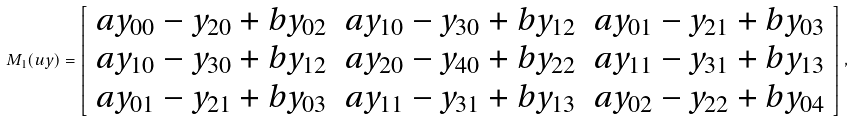Convert formula to latex. <formula><loc_0><loc_0><loc_500><loc_500>{ M } _ { 1 } ( u y ) = \left [ \begin{array} { c c c c c c } a y _ { 0 0 } - y _ { 2 0 } + b y _ { 0 2 } & a y _ { 1 0 } - y _ { 3 0 } + b y _ { 1 2 } & a y _ { 0 1 } - y _ { 2 1 } + b y _ { 0 3 } \\ a y _ { 1 0 } - y _ { 3 0 } + b y _ { 1 2 } & a y _ { 2 0 } - y _ { 4 0 } + b y _ { 2 2 } & a y _ { 1 1 } - y _ { 3 1 } + b y _ { 1 3 } \\ a y _ { 0 1 } - y _ { 2 1 } + b y _ { 0 3 } & a y _ { 1 1 } - y _ { 3 1 } + b y _ { 1 3 } & a y _ { 0 2 } - y _ { 2 2 } + b y _ { 0 4 } \end{array} \right ] ,</formula> 